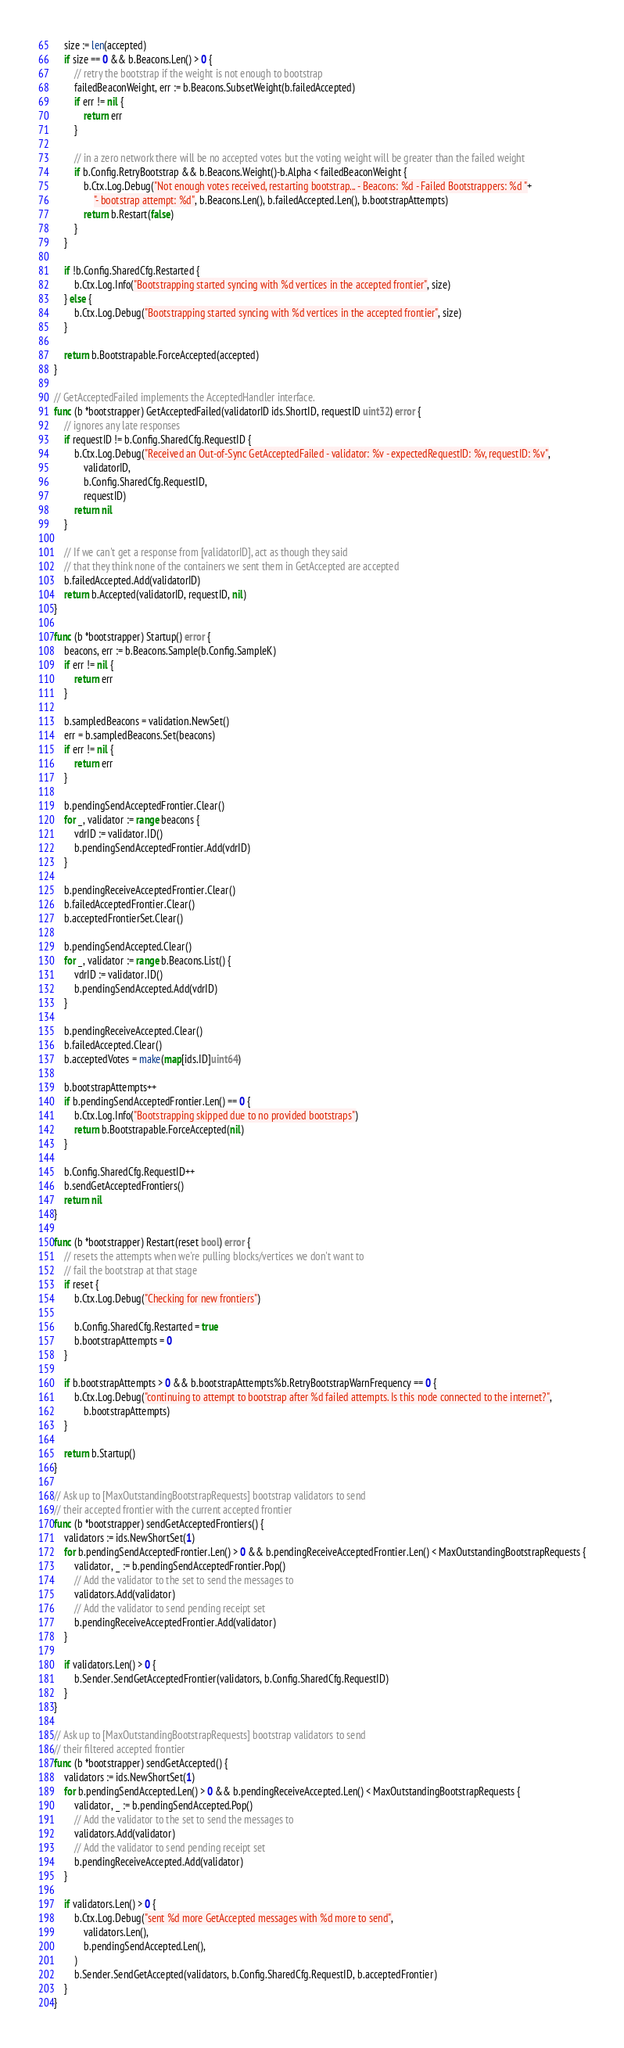Convert code to text. <code><loc_0><loc_0><loc_500><loc_500><_Go_>	size := len(accepted)
	if size == 0 && b.Beacons.Len() > 0 {
		// retry the bootstrap if the weight is not enough to bootstrap
		failedBeaconWeight, err := b.Beacons.SubsetWeight(b.failedAccepted)
		if err != nil {
			return err
		}

		// in a zero network there will be no accepted votes but the voting weight will be greater than the failed weight
		if b.Config.RetryBootstrap && b.Beacons.Weight()-b.Alpha < failedBeaconWeight {
			b.Ctx.Log.Debug("Not enough votes received, restarting bootstrap... - Beacons: %d - Failed Bootstrappers: %d "+
				"- bootstrap attempt: %d", b.Beacons.Len(), b.failedAccepted.Len(), b.bootstrapAttempts)
			return b.Restart(false)
		}
	}

	if !b.Config.SharedCfg.Restarted {
		b.Ctx.Log.Info("Bootstrapping started syncing with %d vertices in the accepted frontier", size)
	} else {
		b.Ctx.Log.Debug("Bootstrapping started syncing with %d vertices in the accepted frontier", size)
	}

	return b.Bootstrapable.ForceAccepted(accepted)
}

// GetAcceptedFailed implements the AcceptedHandler interface.
func (b *bootstrapper) GetAcceptedFailed(validatorID ids.ShortID, requestID uint32) error {
	// ignores any late responses
	if requestID != b.Config.SharedCfg.RequestID {
		b.Ctx.Log.Debug("Received an Out-of-Sync GetAcceptedFailed - validator: %v - expectedRequestID: %v, requestID: %v",
			validatorID,
			b.Config.SharedCfg.RequestID,
			requestID)
		return nil
	}

	// If we can't get a response from [validatorID], act as though they said
	// that they think none of the containers we sent them in GetAccepted are accepted
	b.failedAccepted.Add(validatorID)
	return b.Accepted(validatorID, requestID, nil)
}

func (b *bootstrapper) Startup() error {
	beacons, err := b.Beacons.Sample(b.Config.SampleK)
	if err != nil {
		return err
	}

	b.sampledBeacons = validation.NewSet()
	err = b.sampledBeacons.Set(beacons)
	if err != nil {
		return err
	}

	b.pendingSendAcceptedFrontier.Clear()
	for _, validator := range beacons {
		vdrID := validator.ID()
		b.pendingSendAcceptedFrontier.Add(vdrID)
	}

	b.pendingReceiveAcceptedFrontier.Clear()
	b.failedAcceptedFrontier.Clear()
	b.acceptedFrontierSet.Clear()

	b.pendingSendAccepted.Clear()
	for _, validator := range b.Beacons.List() {
		vdrID := validator.ID()
		b.pendingSendAccepted.Add(vdrID)
	}

	b.pendingReceiveAccepted.Clear()
	b.failedAccepted.Clear()
	b.acceptedVotes = make(map[ids.ID]uint64)

	b.bootstrapAttempts++
	if b.pendingSendAcceptedFrontier.Len() == 0 {
		b.Ctx.Log.Info("Bootstrapping skipped due to no provided bootstraps")
		return b.Bootstrapable.ForceAccepted(nil)
	}

	b.Config.SharedCfg.RequestID++
	b.sendGetAcceptedFrontiers()
	return nil
}

func (b *bootstrapper) Restart(reset bool) error {
	// resets the attempts when we're pulling blocks/vertices we don't want to
	// fail the bootstrap at that stage
	if reset {
		b.Ctx.Log.Debug("Checking for new frontiers")

		b.Config.SharedCfg.Restarted = true
		b.bootstrapAttempts = 0
	}

	if b.bootstrapAttempts > 0 && b.bootstrapAttempts%b.RetryBootstrapWarnFrequency == 0 {
		b.Ctx.Log.Debug("continuing to attempt to bootstrap after %d failed attempts. Is this node connected to the internet?",
			b.bootstrapAttempts)
	}

	return b.Startup()
}

// Ask up to [MaxOutstandingBootstrapRequests] bootstrap validators to send
// their accepted frontier with the current accepted frontier
func (b *bootstrapper) sendGetAcceptedFrontiers() {
	validators := ids.NewShortSet(1)
	for b.pendingSendAcceptedFrontier.Len() > 0 && b.pendingReceiveAcceptedFrontier.Len() < MaxOutstandingBootstrapRequests {
		validator, _ := b.pendingSendAcceptedFrontier.Pop()
		// Add the validator to the set to send the messages to
		validators.Add(validator)
		// Add the validator to send pending receipt set
		b.pendingReceiveAcceptedFrontier.Add(validator)
	}

	if validators.Len() > 0 {
		b.Sender.SendGetAcceptedFrontier(validators, b.Config.SharedCfg.RequestID)
	}
}

// Ask up to [MaxOutstandingBootstrapRequests] bootstrap validators to send
// their filtered accepted frontier
func (b *bootstrapper) sendGetAccepted() {
	validators := ids.NewShortSet(1)
	for b.pendingSendAccepted.Len() > 0 && b.pendingReceiveAccepted.Len() < MaxOutstandingBootstrapRequests {
		validator, _ := b.pendingSendAccepted.Pop()
		// Add the validator to the set to send the messages to
		validators.Add(validator)
		// Add the validator to send pending receipt set
		b.pendingReceiveAccepted.Add(validator)
	}

	if validators.Len() > 0 {
		b.Ctx.Log.Debug("sent %d more GetAccepted messages with %d more to send",
			validators.Len(),
			b.pendingSendAccepted.Len(),
		)
		b.Sender.SendGetAccepted(validators, b.Config.SharedCfg.RequestID, b.acceptedFrontier)
	}
}
</code> 